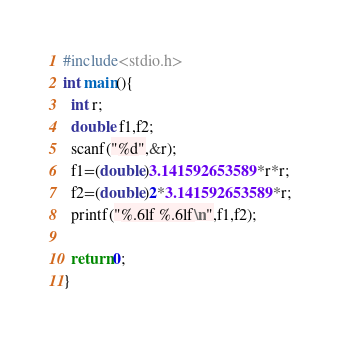<code> <loc_0><loc_0><loc_500><loc_500><_C_>#include<stdio.h>
int main(){
  int r;
  double f1,f2; 
  scanf("%d",&r);
  f1=(double)3.141592653589*r*r;
  f2=(double)2*3.141592653589*r;
  printf("%.6lf %.6lf\n",f1,f2); 

  return 0;
}</code> 